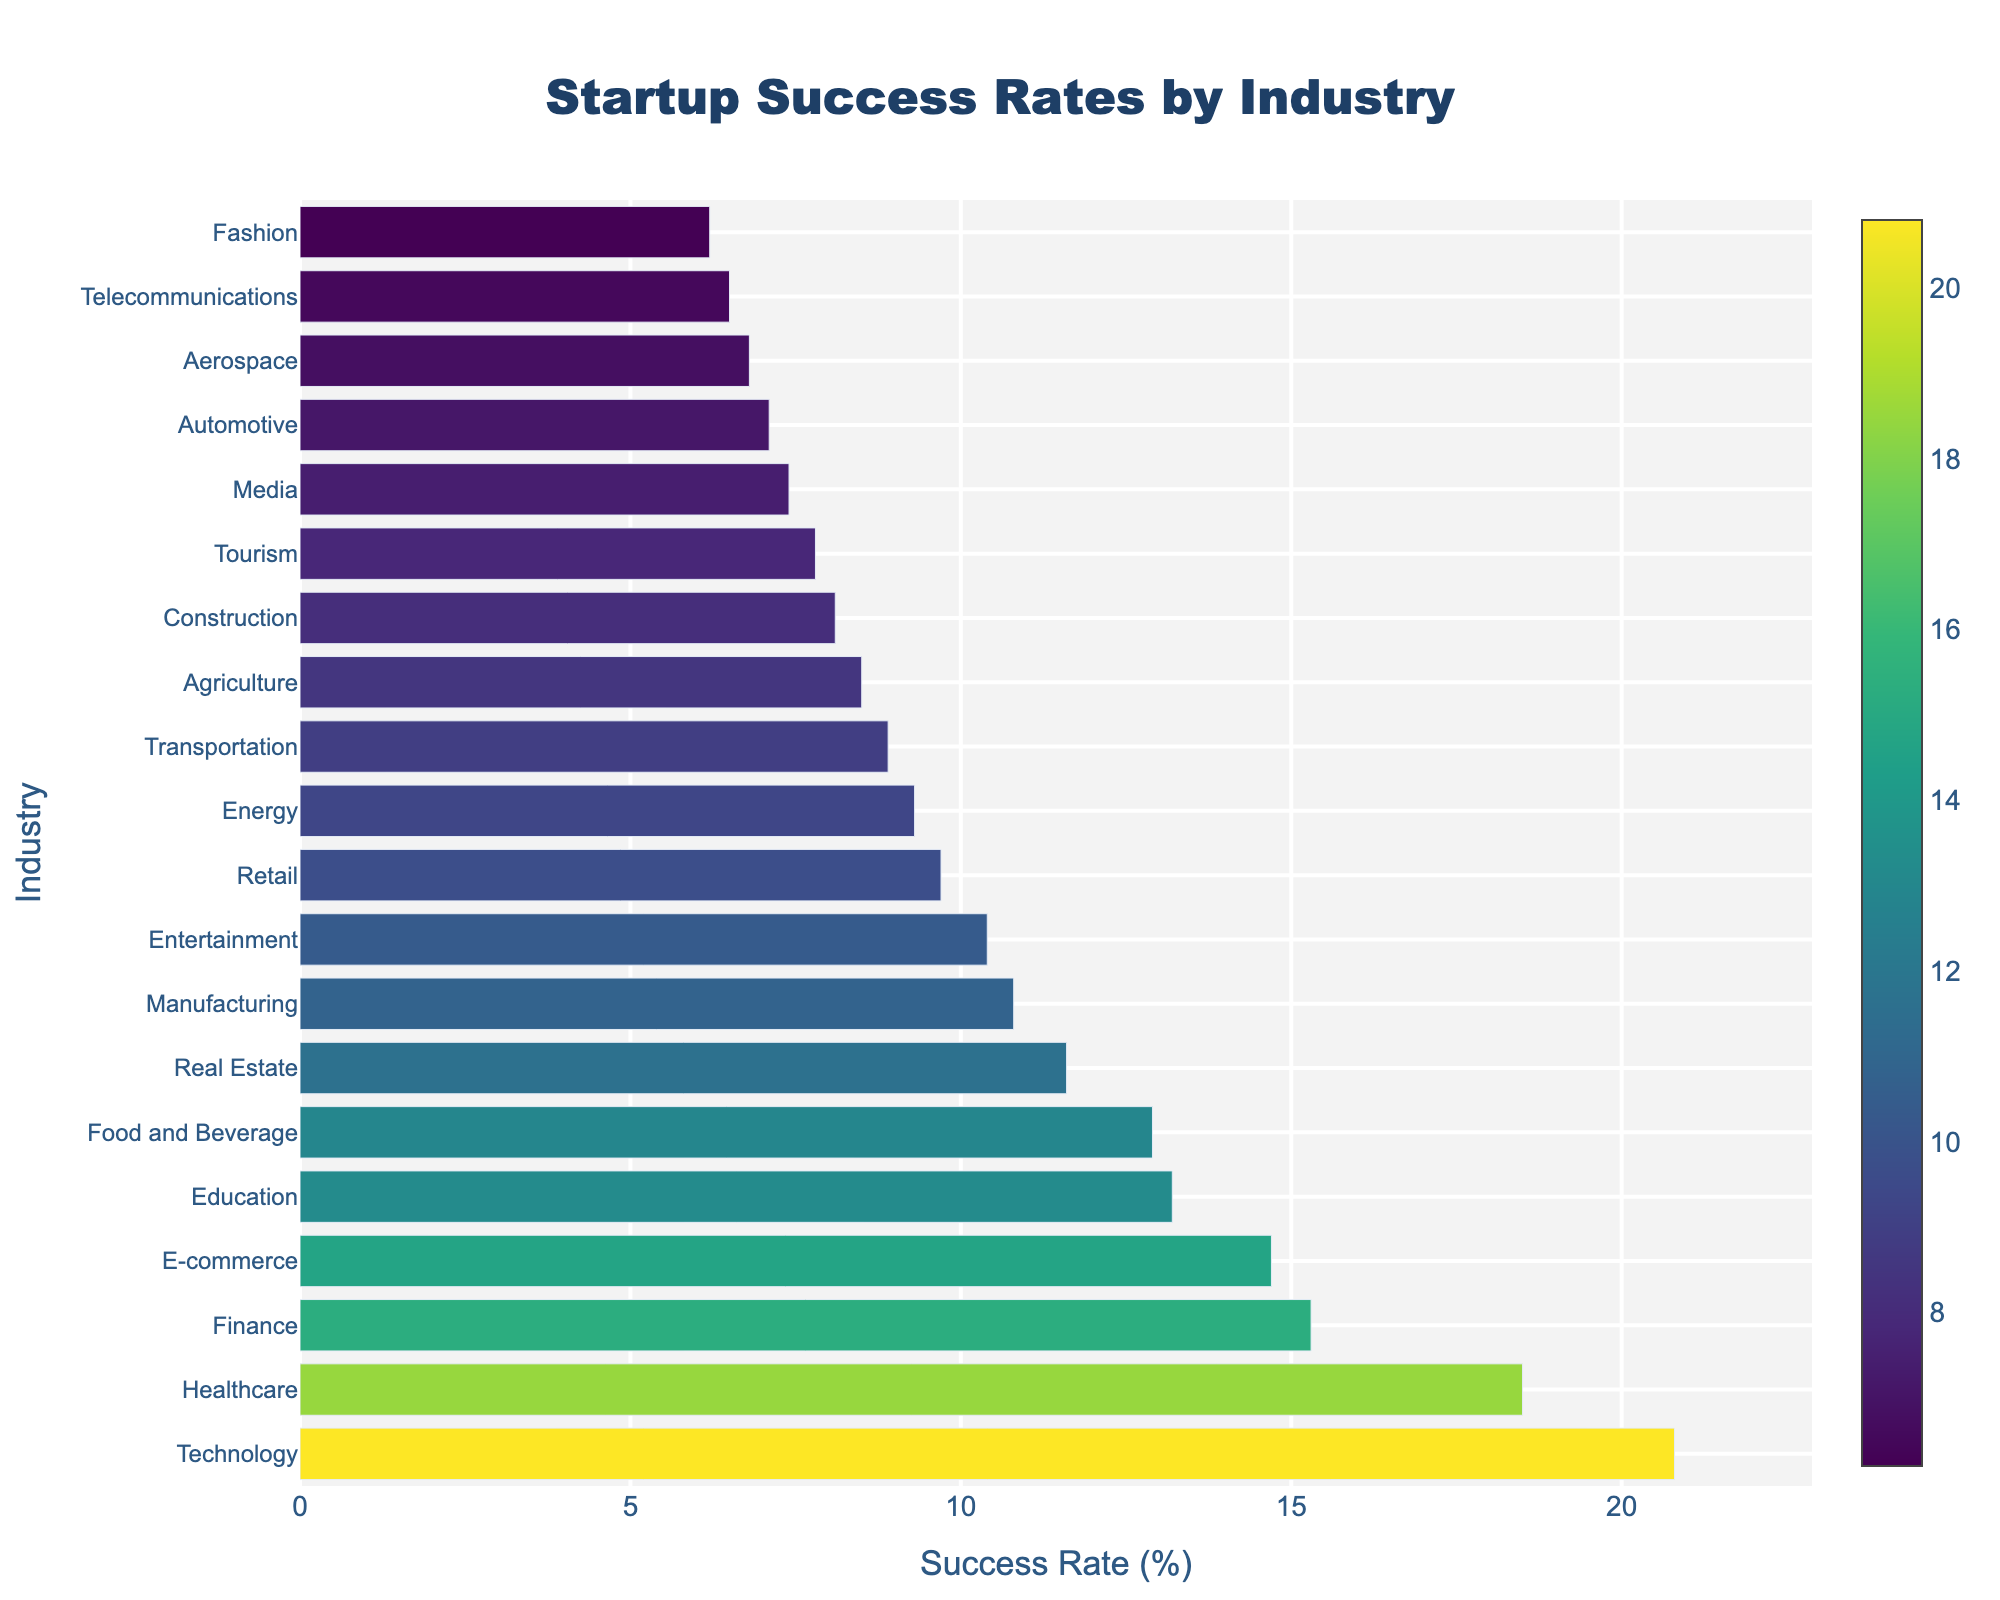Which industry sector has the highest startup success rate? The highest bar on the chart represents the industry with the highest success rate. The bar for Technology is the tallest.
Answer: Technology What is the difference in the success rate between the Healthcare and Finance sectors? The success rate for Healthcare is 18.5% and for Finance is 15.3%. The difference is calculated as 18.5 - 15.3 = 3.2%.
Answer: 3.2% Which industry sector performs better, E-commerce or Education? By comparing the lengths of the bars for E-commerce and Education, we see that E-commerce has a success rate of 14.7%, while Education has 13.2%. Since 14.7% is greater than 13.2%, E-commerce performs better.
Answer: E-commerce How many industry sectors have a success rate higher than 10%? Count the number of bars that extend beyond the 10% mark. The industries above 10% are Technology, Healthcare, Finance, E-commerce, Education, Food and Beverage, Real Estate, and Manufacturing, totaling 8 sectors.
Answer: 8 What is the average success rate of the Technology, Healthcare, and Finance sectors? Sum the success rates of Technology (20.8%), Healthcare (18.5%), and Finance (15.3%), and divide by 3. (20.8 + 18.5 + 15.3) / 3 = 54.6 / 3 = 18.2%.
Answer: 18.2% Which sector has a nearly similar success rate as Retail? Look for bars near the same length as Retail's bar. Retail has a success rate of 9.7%, and Energy, with a success rate of 9.3%, is the closest.
Answer: Energy By how much does the success rate of the Food and Beverage sector exceed that of the Construction sector? The Food and Beverage sector has a success rate of 12.9%, and the Construction sector has 8.1%. The difference is 12.9 - 8.1 = 4.8%.
Answer: 4.8% What is the success rate for the sector with the second lowest rate? Identify the second smallest bar, which corresponds to the Fashion sector with a success rate of 6.2%.
Answer: 6.2% What is the median success rate among all the industry sectors? First, list all the success rates in ascending order, then find the middle value. The middle value, or median, is the success rate of the Food and Beverage sector (the 10th value in the list).
Answer: 12.9% Between Agriculture and Aerospace, which sector has a higher startup success rate? By comparing the heights of the bars for Agriculture (8.5%) and Aerospace (6.8%), it's clear that Agriculture has a higher rate.
Answer: Agriculture 